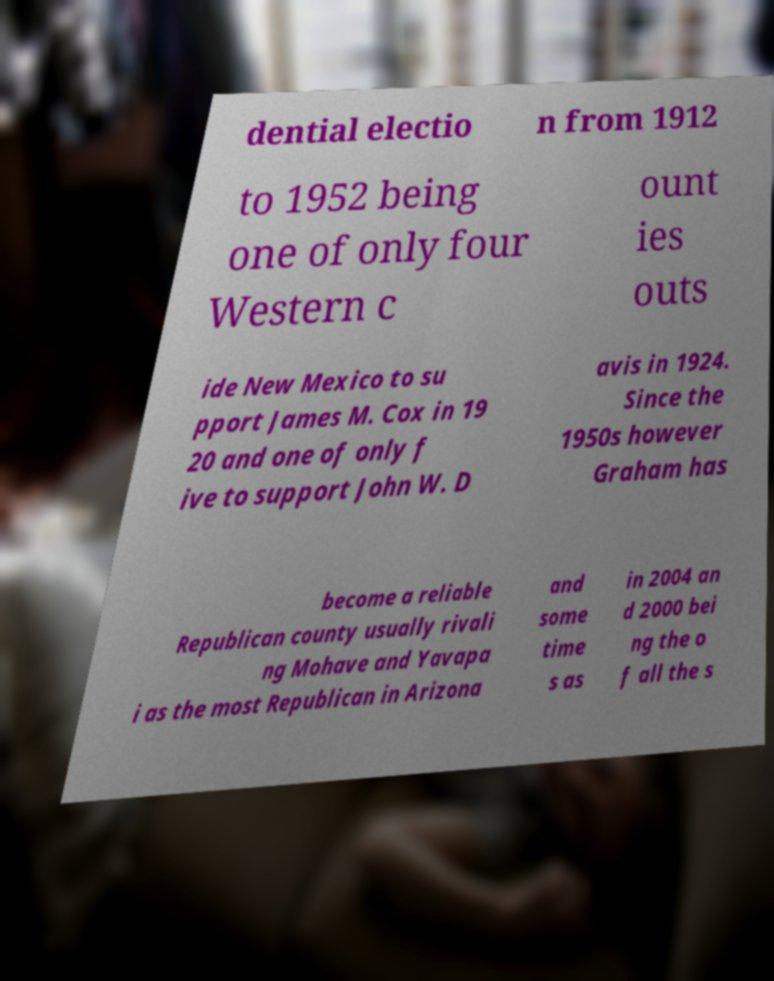Could you assist in decoding the text presented in this image and type it out clearly? dential electio n from 1912 to 1952 being one of only four Western c ount ies outs ide New Mexico to su pport James M. Cox in 19 20 and one of only f ive to support John W. D avis in 1924. Since the 1950s however Graham has become a reliable Republican county usually rivali ng Mohave and Yavapa i as the most Republican in Arizona and some time s as in 2004 an d 2000 bei ng the o f all the s 